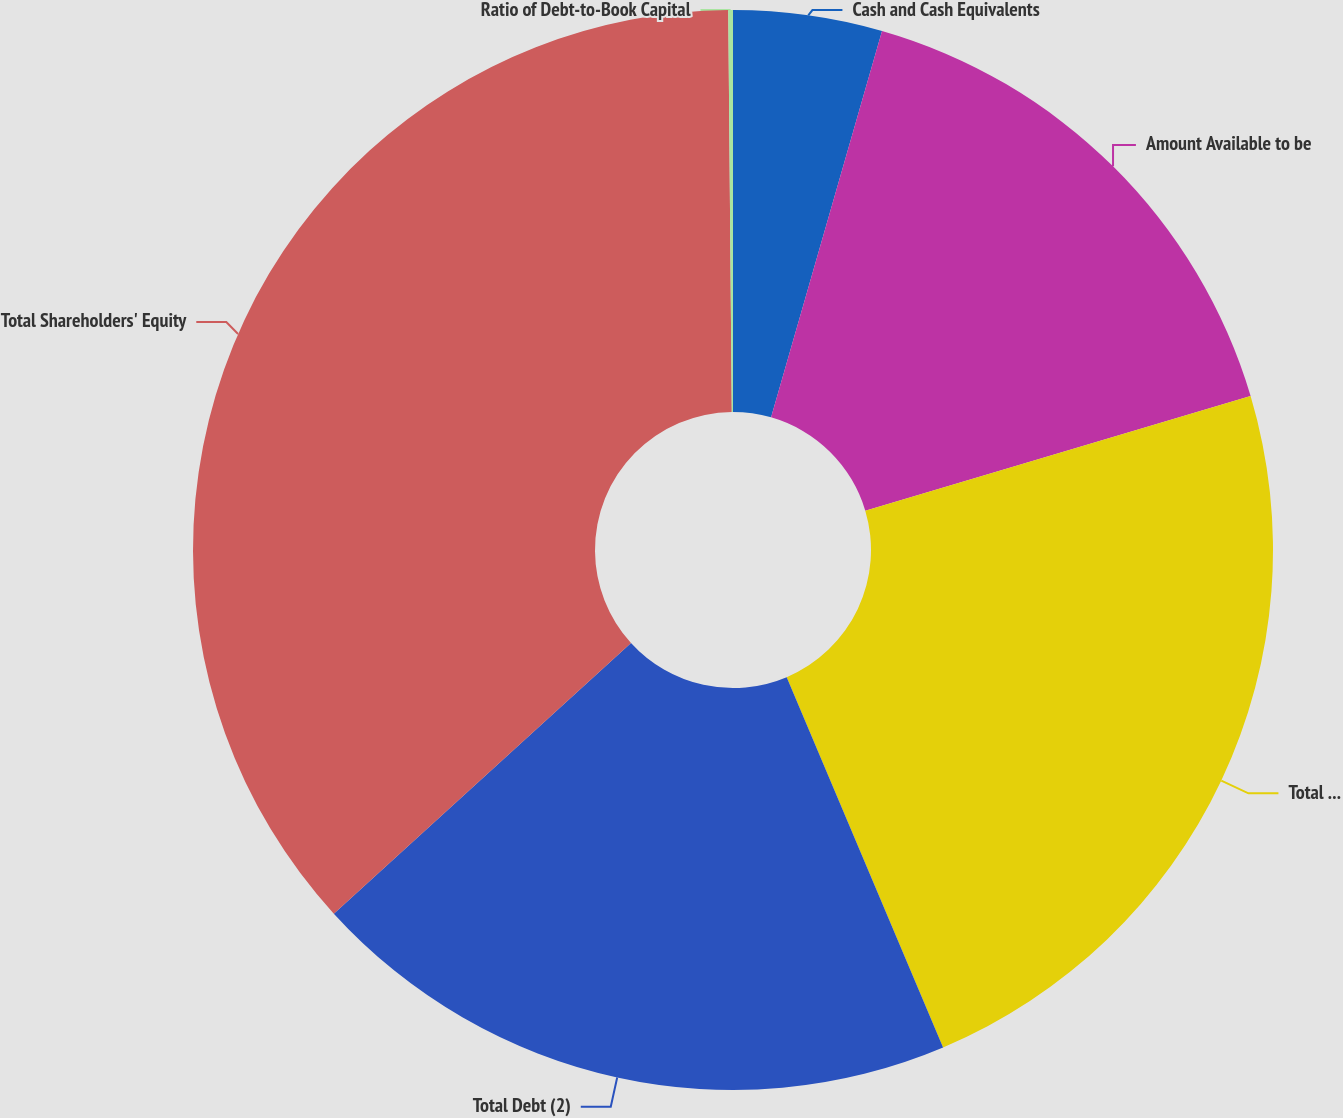<chart> <loc_0><loc_0><loc_500><loc_500><pie_chart><fcel>Cash and Cash Equivalents<fcel>Amount Available to be<fcel>Total Liquidity<fcel>Total Debt (2)<fcel>Total Shareholders' Equity<fcel>Ratio of Debt-to-Book Capital<nl><fcel>4.45%<fcel>15.95%<fcel>23.24%<fcel>19.6%<fcel>36.62%<fcel>0.14%<nl></chart> 